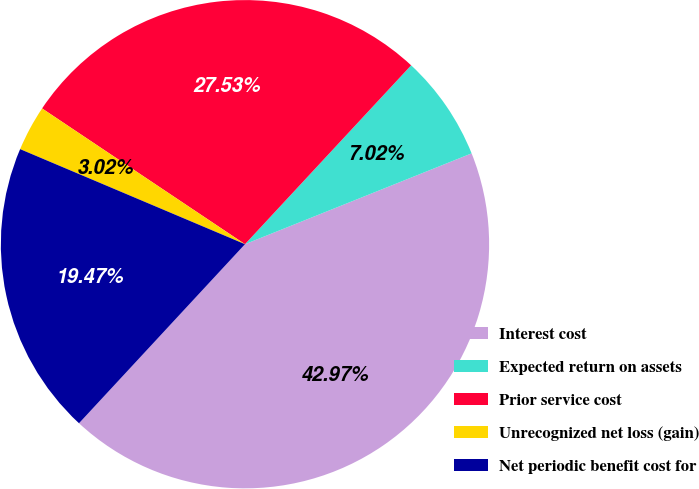Convert chart. <chart><loc_0><loc_0><loc_500><loc_500><pie_chart><fcel>Interest cost<fcel>Expected return on assets<fcel>Prior service cost<fcel>Unrecognized net loss (gain)<fcel>Net periodic benefit cost for<nl><fcel>42.97%<fcel>7.02%<fcel>27.53%<fcel>3.02%<fcel>19.47%<nl></chart> 